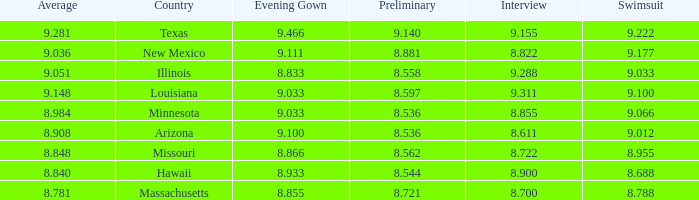What was the swimsuit score for Illinois? 9.033. 